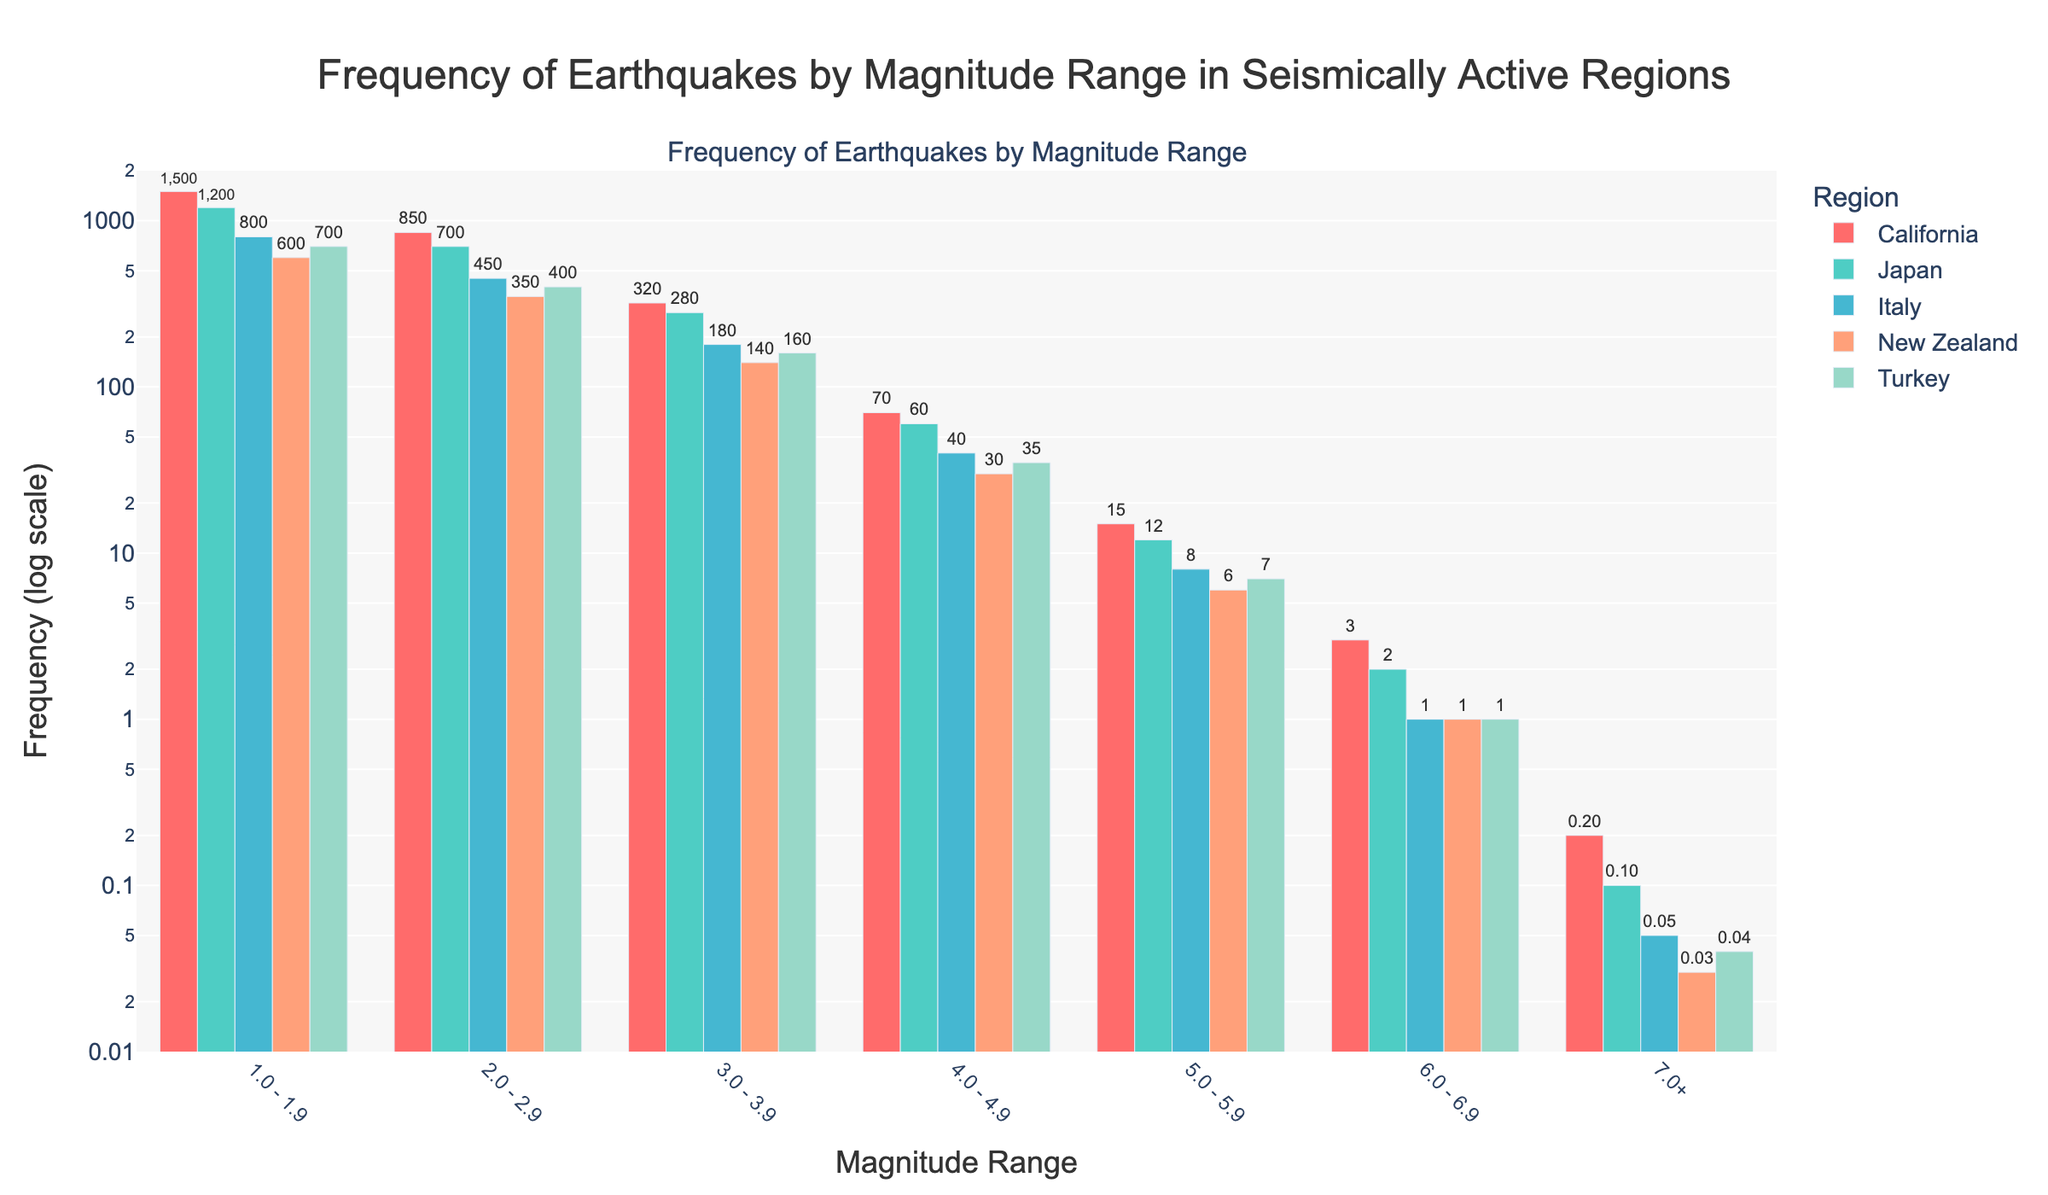What's the approximate total number of earthquakes with a magnitude less than 3.0 in Japan and California combined? First, find the total number of earthquakes with magnitudes 1.0-1.9 and 2.0-2.9 separately for Japan and California. For Japan: 1200 + 700 = 1900. For California: 1500 + 850 = 2350. Then, add these totals: 1900 + 2350 = 4250.
Answer: 4250 Which region has the highest frequency of earthquakes in the 4.0-4.9 magnitude range? Compare the bars for the 4.0-4.9 magnitude range across all regions: California (70), Japan (60), Italy (40), New Zealand (30), Turkey (35). California has the highest frequency.
Answer: California By how many earthquakes does California's frequency exceed Turkey's frequency in the 1.0-1.9 magnitude range? Look at the frequencies in the 1.0-1.9 magnitude range for California (1500) and Turkey (700). Subtract Turkey's value from California's: 1500 - 700 = 800.
Answer: 800 What is the trend in earthquake frequency as the magnitude range increases from 1.0-1.9 to 7.0+ across all regions? Observe that the frequency of earthquakes consistently decreases as the magnitude range increases from 1.0-1.9 to 7.0+ for all regions in the chart.
Answer: Decreasing Which region has the smallest number of earthquakes in the 7.0+ magnitude range? Compare the frequencies in the 7.0+ magnitude range for all regions: California (0.2), Japan (0.1), Italy (0.05), New Zealand (0.03), Turkey (0.04). New Zealand has the smallest number.
Answer: New Zealand What is the combined total of earthquakes in the 5.0-5.9 and 6.0-6.9 magnitude ranges in New Zealand? First, find the total number of earthquakes in the 5.0-5.9 and 6.0-6.9 magnitude ranges separately for New Zealand. For 5.0-5.9: 6. For 6.0-6.9: 1. Then, the combined total is 6 + 1 = 7.
Answer: 7 Between Japan and Italy, which region has a higher frequency of earthquakes in the 2.0-2.9 magnitude range, and by how much? Compare the frequencies in the 2.0-2.9 magnitude range for Japan (700) and Italy (450). Japan has a higher frequency. Subtract Italy's frequency from Japan's: 700 - 450 = 250.
Answer: Japan, 250 How does the earthquake frequency of New Zealand in the 3.0-3.9 range visually compare to Italy in the same range? The bar representing New Zealand in the 3.0-3.9 magnitude range (140) is shorter than the bar representing Italy (180) in the same range, indicating a lower frequency for New Zealand.
Answer: Shorter Which magnitude range has a frequency value less than 10 for all regions? Observe the frequencies across all regions for each magnitude range. The 6.0-6.9 and 7.0+ magnitude ranges have values less than 10 for all regions.
Answer: 6.0-6.9 and 7.0+ 